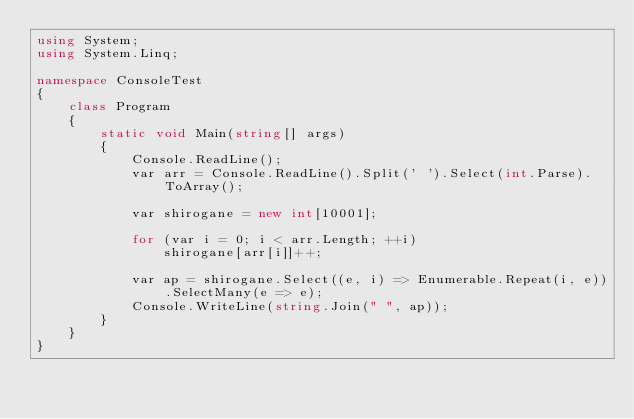<code> <loc_0><loc_0><loc_500><loc_500><_C#_>using System;
using System.Linq;

namespace ConsoleTest
{
    class Program
    {
        static void Main(string[] args)
        {
            Console.ReadLine();
            var arr = Console.ReadLine().Split(' ').Select(int.Parse).ToArray();

            var shirogane = new int[10001];

            for (var i = 0; i < arr.Length; ++i)
                shirogane[arr[i]]++;

            var ap = shirogane.Select((e, i) => Enumerable.Repeat(i, e)).SelectMany(e => e);
            Console.WriteLine(string.Join(" ", ap));
        }
    }
}
</code> 